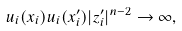<formula> <loc_0><loc_0><loc_500><loc_500>u _ { i } ( x _ { i } ) u _ { i } ( x ^ { \prime } _ { i } ) | z ^ { \prime } _ { i } | ^ { n - 2 } \to \infty ,</formula> 